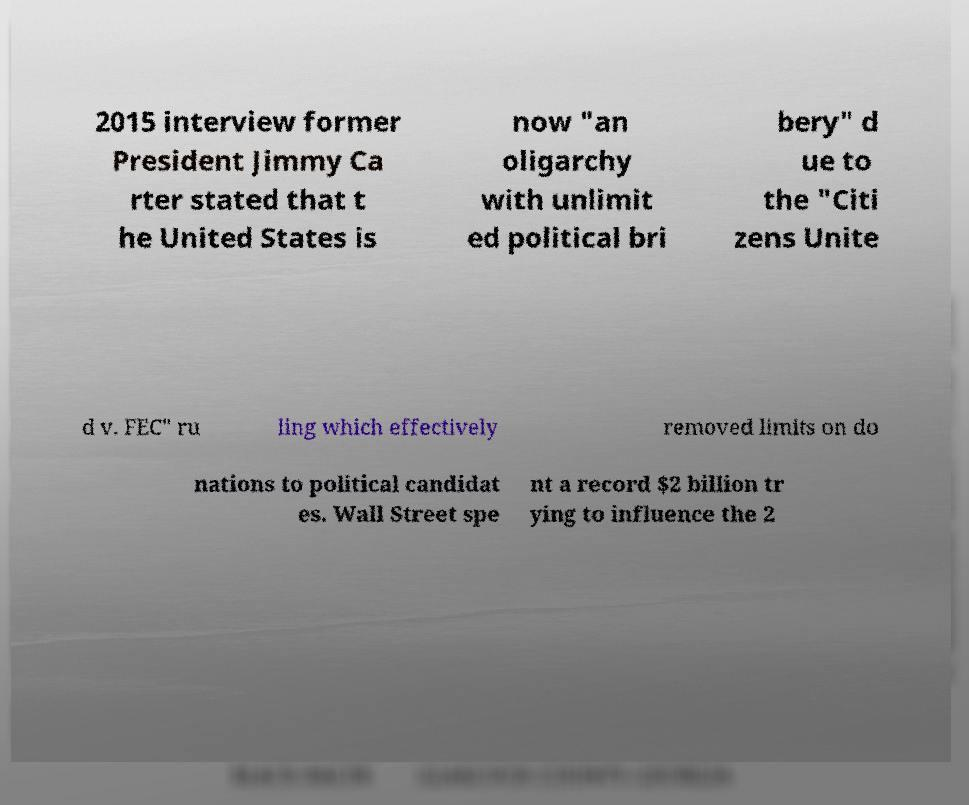Can you read and provide the text displayed in the image?This photo seems to have some interesting text. Can you extract and type it out for me? 2015 interview former President Jimmy Ca rter stated that t he United States is now "an oligarchy with unlimit ed political bri bery" d ue to the "Citi zens Unite d v. FEC" ru ling which effectively removed limits on do nations to political candidat es. Wall Street spe nt a record $2 billion tr ying to influence the 2 